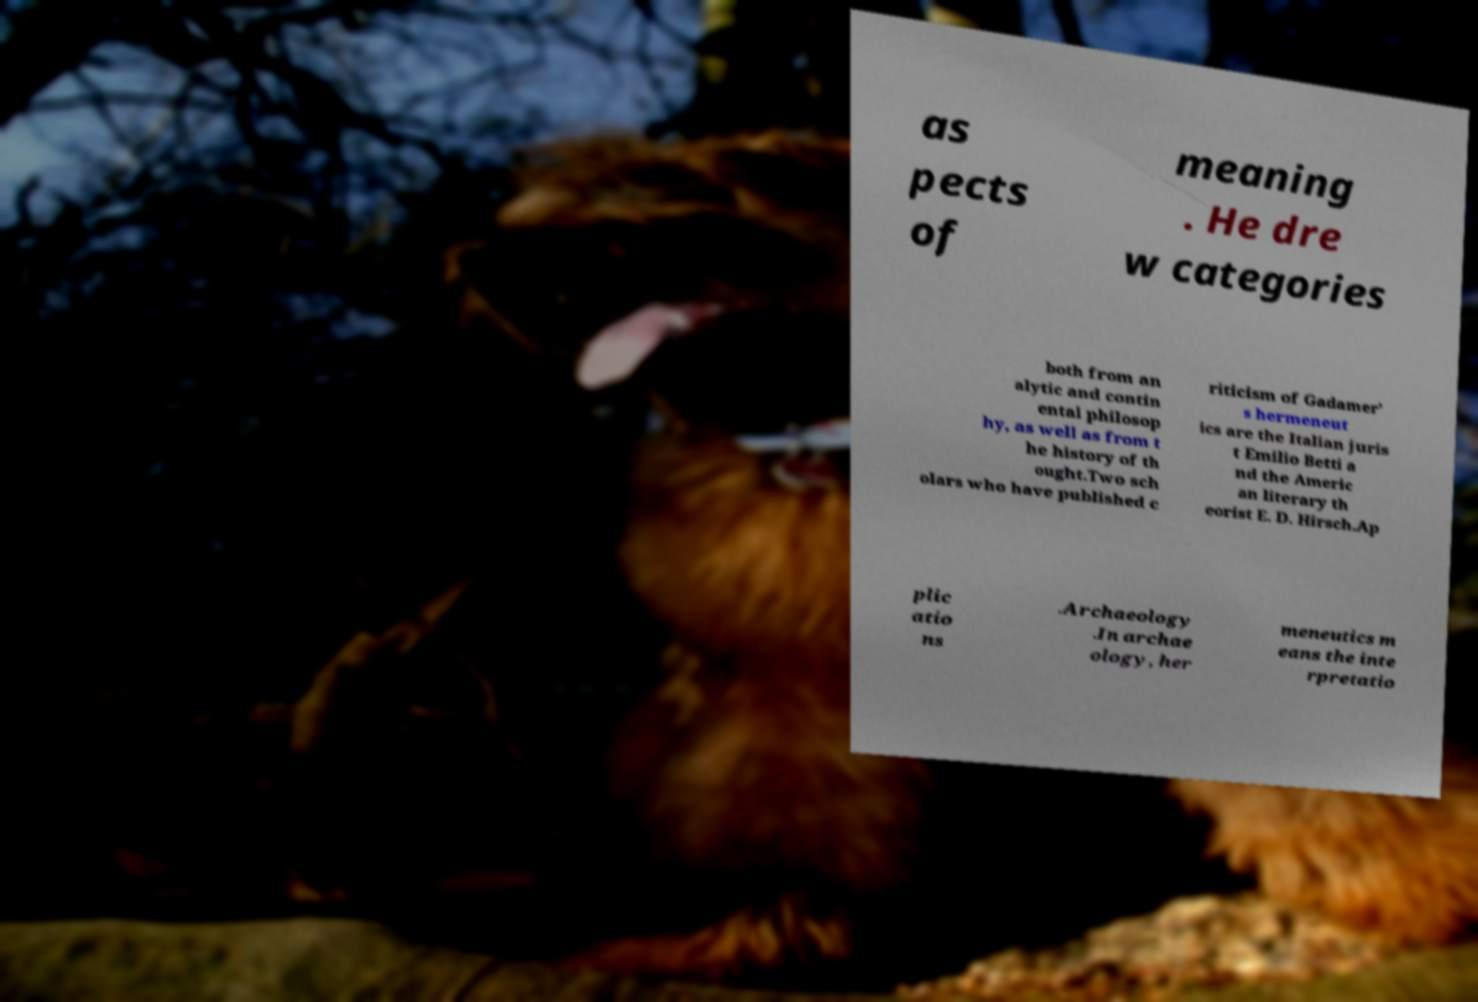Please read and relay the text visible in this image. What does it say? as pects of meaning . He dre w categories both from an alytic and contin ental philosop hy, as well as from t he history of th ought.Two sch olars who have published c riticism of Gadamer' s hermeneut ics are the Italian juris t Emilio Betti a nd the Americ an literary th eorist E. D. Hirsch.Ap plic atio ns .Archaeology .In archae ology, her meneutics m eans the inte rpretatio 